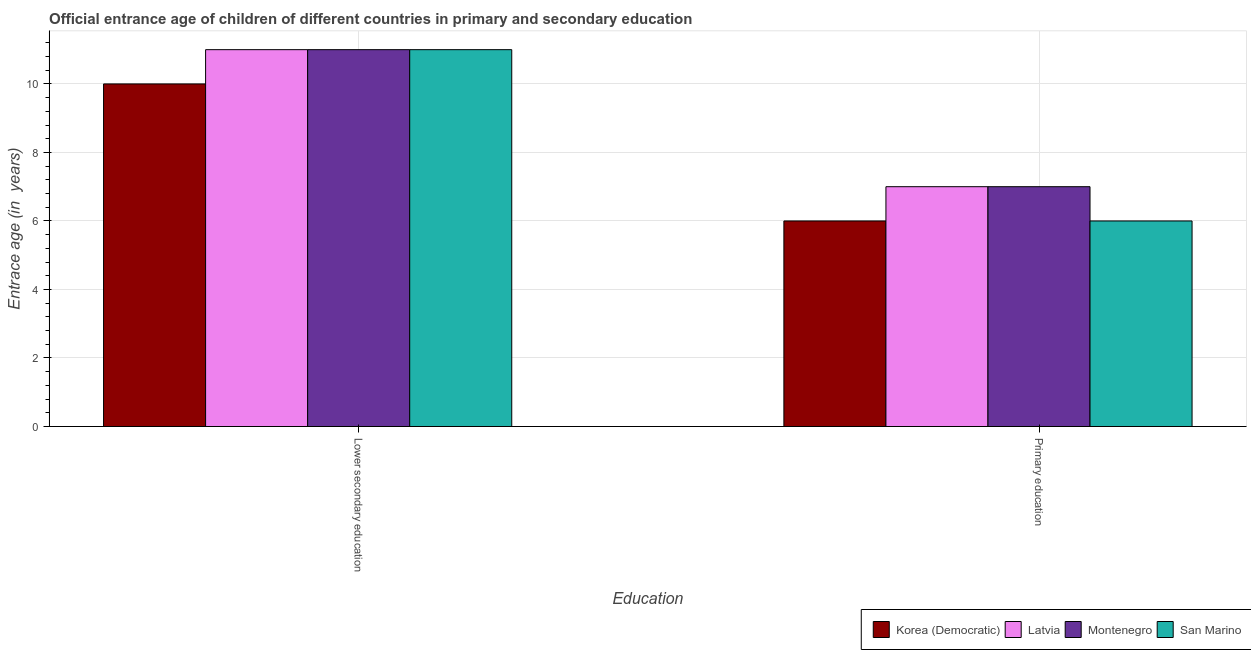How many groups of bars are there?
Give a very brief answer. 2. Are the number of bars on each tick of the X-axis equal?
Offer a terse response. Yes. How many bars are there on the 2nd tick from the left?
Give a very brief answer. 4. How many bars are there on the 2nd tick from the right?
Give a very brief answer. 4. What is the label of the 2nd group of bars from the left?
Ensure brevity in your answer.  Primary education. Across all countries, what is the maximum entrance age of children in lower secondary education?
Your answer should be compact. 11. Across all countries, what is the minimum entrance age of chiildren in primary education?
Provide a succinct answer. 6. In which country was the entrance age of children in lower secondary education maximum?
Keep it short and to the point. Latvia. In which country was the entrance age of chiildren in primary education minimum?
Make the answer very short. Korea (Democratic). What is the total entrance age of children in lower secondary education in the graph?
Ensure brevity in your answer.  43. What is the difference between the entrance age of chiildren in primary education in Latvia and that in San Marino?
Make the answer very short. 1. What is the difference between the entrance age of chiildren in primary education in San Marino and the entrance age of children in lower secondary education in Korea (Democratic)?
Offer a terse response. -4. What is the average entrance age of children in lower secondary education per country?
Your response must be concise. 10.75. What is the difference between the entrance age of chiildren in primary education and entrance age of children in lower secondary education in Latvia?
Your answer should be very brief. -4. What is the ratio of the entrance age of children in lower secondary education in Korea (Democratic) to that in Montenegro?
Offer a terse response. 0.91. Is the entrance age of chiildren in primary education in Latvia less than that in San Marino?
Offer a terse response. No. In how many countries, is the entrance age of children in lower secondary education greater than the average entrance age of children in lower secondary education taken over all countries?
Make the answer very short. 3. What does the 1st bar from the left in Primary education represents?
Offer a very short reply. Korea (Democratic). What does the 4th bar from the right in Primary education represents?
Your answer should be very brief. Korea (Democratic). How many bars are there?
Provide a short and direct response. 8. Are all the bars in the graph horizontal?
Give a very brief answer. No. How many countries are there in the graph?
Offer a terse response. 4. What is the difference between two consecutive major ticks on the Y-axis?
Your answer should be compact. 2. Where does the legend appear in the graph?
Offer a terse response. Bottom right. How many legend labels are there?
Give a very brief answer. 4. What is the title of the graph?
Your response must be concise. Official entrance age of children of different countries in primary and secondary education. What is the label or title of the X-axis?
Ensure brevity in your answer.  Education. What is the label or title of the Y-axis?
Offer a terse response. Entrace age (in  years). What is the Entrace age (in  years) in Montenegro in Lower secondary education?
Offer a very short reply. 11. What is the Entrace age (in  years) in Korea (Democratic) in Primary education?
Give a very brief answer. 6. What is the Entrace age (in  years) in Latvia in Primary education?
Keep it short and to the point. 7. What is the Entrace age (in  years) in San Marino in Primary education?
Make the answer very short. 6. Across all Education, what is the maximum Entrace age (in  years) of Montenegro?
Your answer should be very brief. 11. Across all Education, what is the minimum Entrace age (in  years) of San Marino?
Provide a succinct answer. 6. What is the total Entrace age (in  years) in Korea (Democratic) in the graph?
Make the answer very short. 16. What is the total Entrace age (in  years) of Montenegro in the graph?
Provide a short and direct response. 18. What is the difference between the Entrace age (in  years) of Korea (Democratic) in Lower secondary education and that in Primary education?
Give a very brief answer. 4. What is the difference between the Entrace age (in  years) of Latvia in Lower secondary education and that in Primary education?
Give a very brief answer. 4. What is the difference between the Entrace age (in  years) in Montenegro in Lower secondary education and that in Primary education?
Offer a very short reply. 4. What is the difference between the Entrace age (in  years) in Korea (Democratic) in Lower secondary education and the Entrace age (in  years) in Montenegro in Primary education?
Your answer should be very brief. 3. What is the difference between the Entrace age (in  years) of Montenegro in Lower secondary education and the Entrace age (in  years) of San Marino in Primary education?
Offer a terse response. 5. What is the average Entrace age (in  years) of San Marino per Education?
Provide a short and direct response. 8.5. What is the difference between the Entrace age (in  years) of Korea (Democratic) and Entrace age (in  years) of Latvia in Primary education?
Ensure brevity in your answer.  -1. What is the difference between the Entrace age (in  years) in Korea (Democratic) and Entrace age (in  years) in San Marino in Primary education?
Ensure brevity in your answer.  0. What is the difference between the Entrace age (in  years) of Latvia and Entrace age (in  years) of San Marino in Primary education?
Give a very brief answer. 1. What is the difference between the Entrace age (in  years) in Montenegro and Entrace age (in  years) in San Marino in Primary education?
Your answer should be compact. 1. What is the ratio of the Entrace age (in  years) of Latvia in Lower secondary education to that in Primary education?
Provide a succinct answer. 1.57. What is the ratio of the Entrace age (in  years) of Montenegro in Lower secondary education to that in Primary education?
Ensure brevity in your answer.  1.57. What is the ratio of the Entrace age (in  years) of San Marino in Lower secondary education to that in Primary education?
Make the answer very short. 1.83. What is the difference between the highest and the second highest Entrace age (in  years) in Latvia?
Keep it short and to the point. 4. What is the difference between the highest and the lowest Entrace age (in  years) in Korea (Democratic)?
Ensure brevity in your answer.  4. What is the difference between the highest and the lowest Entrace age (in  years) of Latvia?
Make the answer very short. 4. What is the difference between the highest and the lowest Entrace age (in  years) of Montenegro?
Keep it short and to the point. 4. What is the difference between the highest and the lowest Entrace age (in  years) of San Marino?
Your answer should be very brief. 5. 